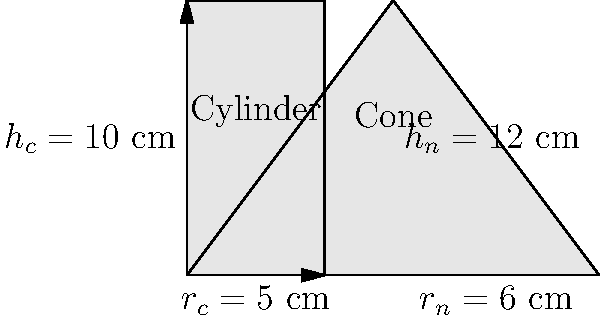As a bartender, you're preparing for a game watch party and need to calculate the volume of beer in different glasses. You have two types of glasses: a cylindrical mug and a conical glass. The cylindrical mug has a height of 10 cm and a radius of 5 cm. The conical glass has a height of 12 cm and a base radius of 6 cm. What is the difference in volume between the cylindrical mug and the conical glass, rounded to the nearest mL? Let's calculate the volumes step by step:

1. Volume of the cylindrical mug:
   The formula for the volume of a cylinder is $V_c = \pi r^2 h$
   $V_c = \pi \cdot (5\text{ cm})^2 \cdot 10\text{ cm}$
   $V_c = 250\pi\text{ cm}^3 \approx 785.40\text{ mL}$

2. Volume of the conical glass:
   The formula for the volume of a cone is $V_n = \frac{1}{3}\pi r^2 h$
   $V_n = \frac{1}{3}\pi \cdot (6\text{ cm})^2 \cdot 12\text{ cm}$
   $V_n = 144\pi\text{ cm}^3 \approx 452.39\text{ mL}$

3. Difference in volume:
   $\text{Difference} = V_c - V_n$
   $\text{Difference} = 785.40\text{ mL} - 452.39\text{ mL} = 333.01\text{ mL}$

4. Rounding to the nearest mL:
   $333.01\text{ mL} \approx 333\text{ mL}$

Therefore, the cylindrical mug can hold approximately 333 mL more beer than the conical glass.
Answer: 333 mL 